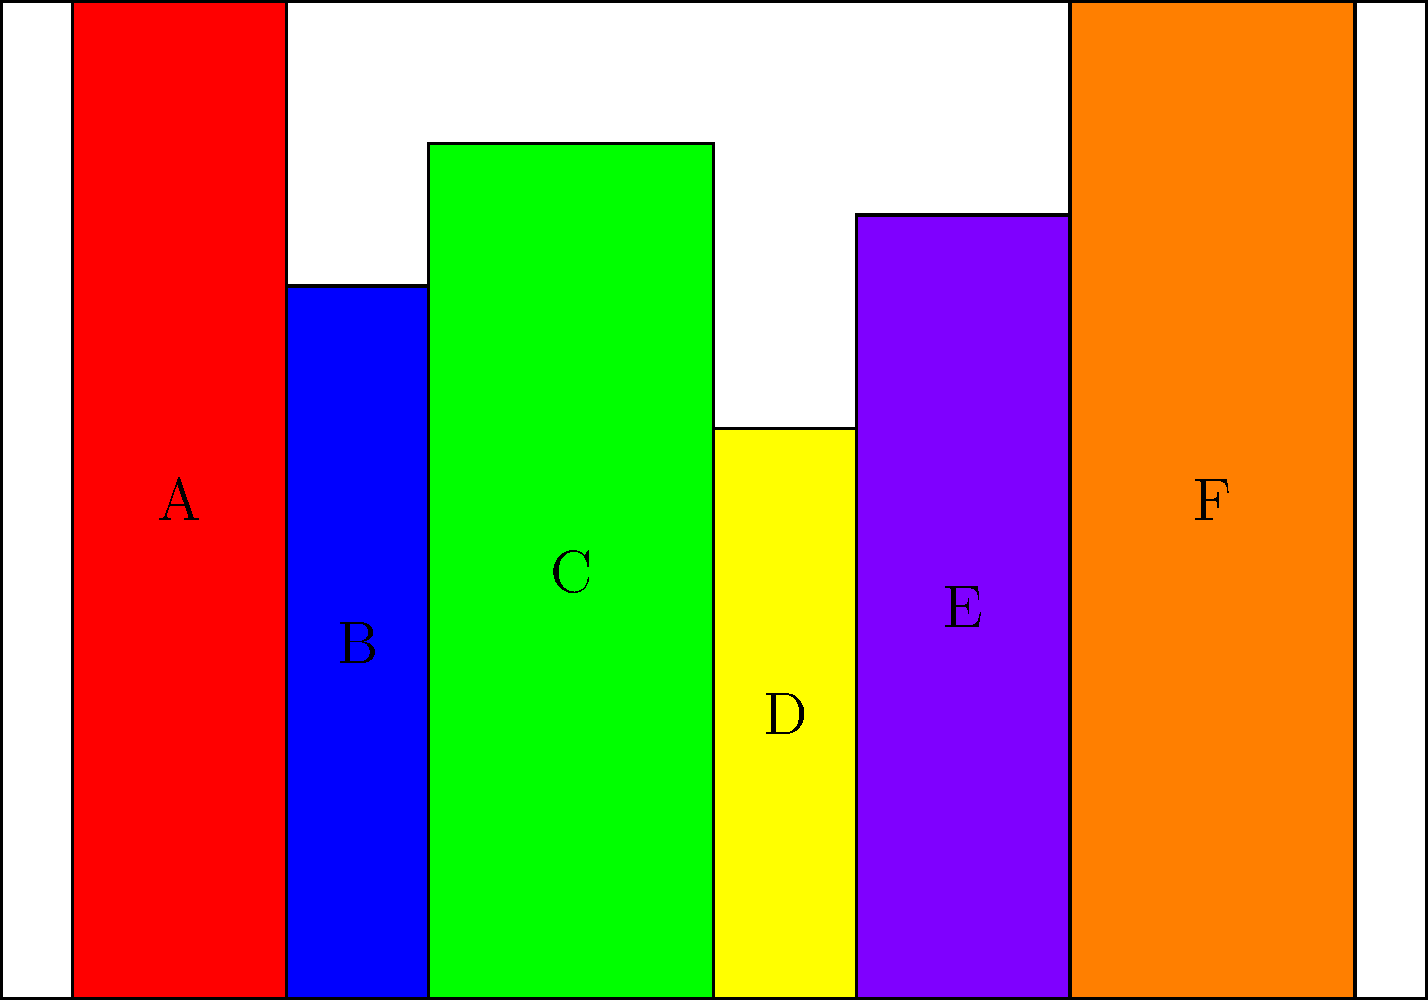Given the visual arrangement of book spines on a bookshelf, which book should be placed between books C and E to create a symmetrical pattern based on height? To solve this visual puzzle, we need to analyze the heights of the books and identify the pattern:

1. First, observe the current arrangement of book heights:
   A (tallest) - B (medium) - C (tall) - D (short) - E (medium-tall) - F (tallest)

2. To create a symmetrical pattern, we need to mirror the heights from the center:
   A (tallest) - B (medium) - C (tall) | ? | E (medium-tall) - F (tallest)

3. The missing book should mirror book C in height to create symmetry.

4. Book D is currently the shortest and doesn't fit the symmetrical pattern.

5. The correct placement would be:
   A (tallest) - B (medium) - C (tall) | D (short) | E (medium-tall) - F (tallest)

6. This arrangement creates a symmetrical pattern with heights decreasing towards the center and then increasing again.

Therefore, book D should be placed between books C and E to create a symmetrical pattern based on height.
Answer: D 